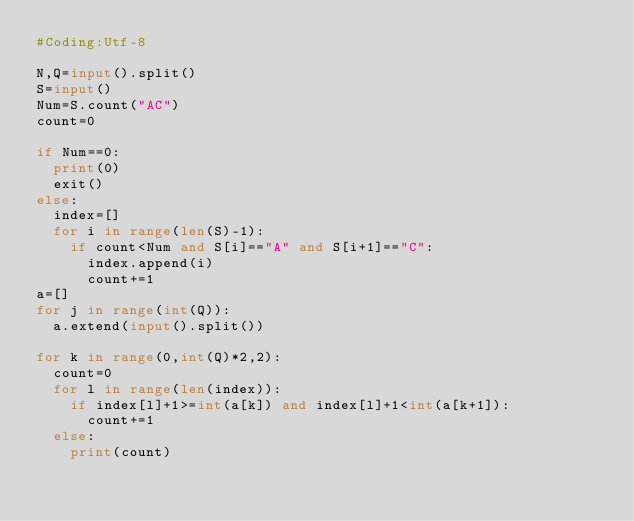Convert code to text. <code><loc_0><loc_0><loc_500><loc_500><_Python_>#Coding:Utf-8

N,Q=input().split()
S=input()
Num=S.count("AC")
count=0

if Num==0:
  print(0)
  exit()
else:
  index=[]
  for i in range(len(S)-1):
    if count<Num and S[i]=="A" and S[i+1]=="C":
      index.append(i)
      count+=1
a=[]
for j in range(int(Q)):
  a.extend(input().split())

for k in range(0,int(Q)*2,2):
  count=0
  for l in range(len(index)):
    if index[l]+1>=int(a[k]) and index[l]+1<int(a[k+1]):
      count+=1
  else:
    print(count)</code> 